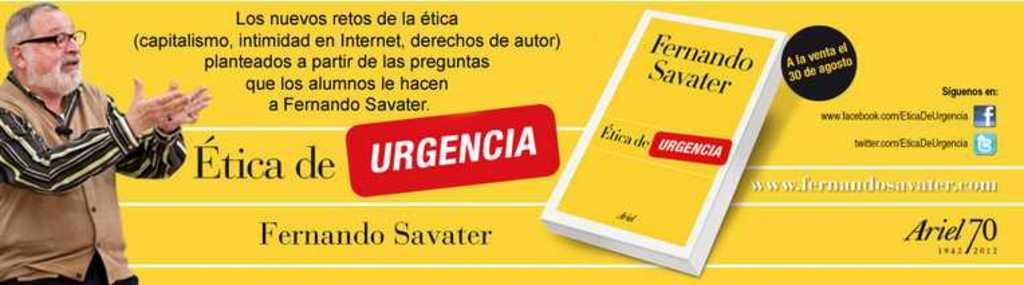<image>
Summarize the visual content of the image. An advertisement for a book by Fernando Savater. 